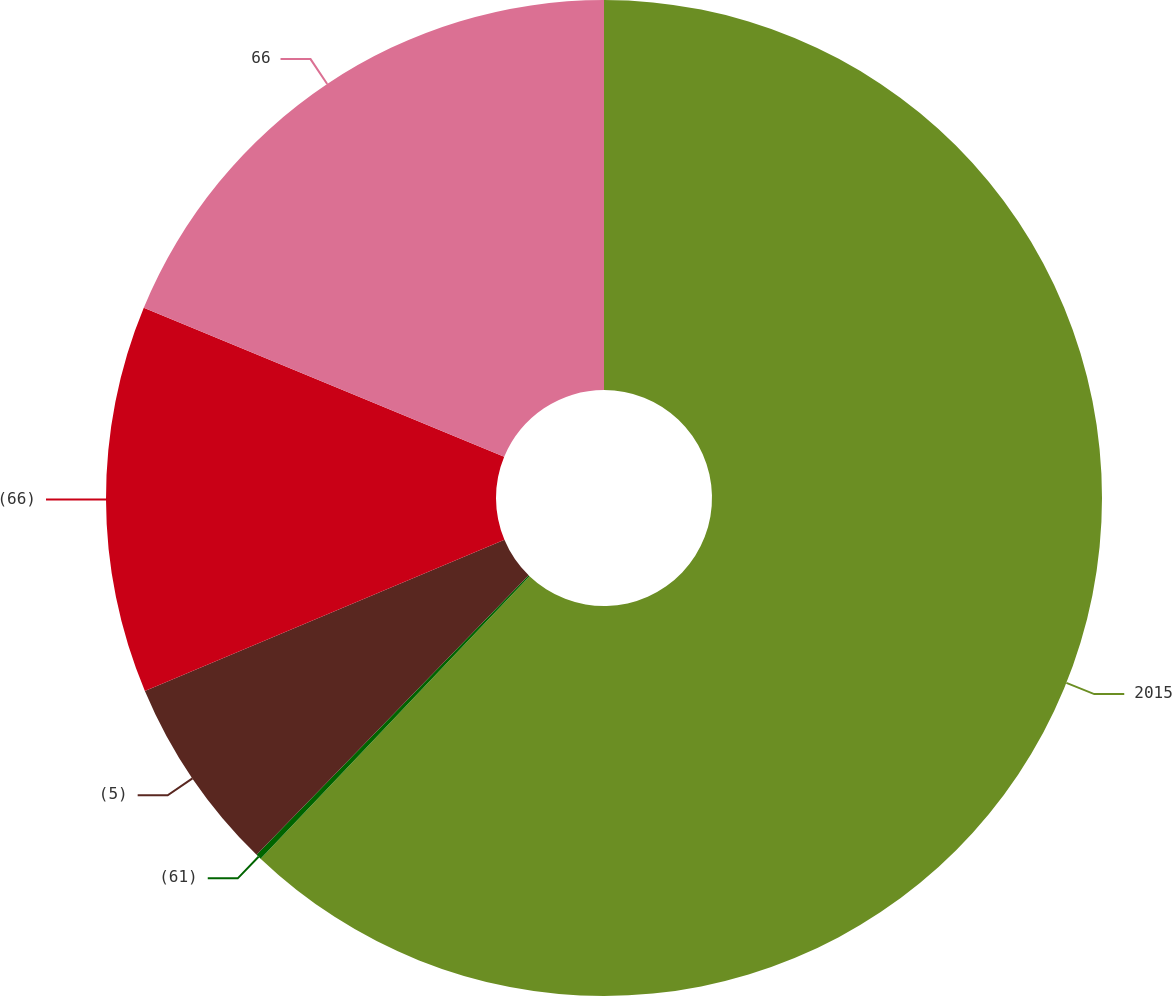Convert chart. <chart><loc_0><loc_0><loc_500><loc_500><pie_chart><fcel>2015<fcel>(61)<fcel>(5)<fcel>(66)<fcel>66<nl><fcel>62.11%<fcel>0.18%<fcel>6.38%<fcel>12.57%<fcel>18.76%<nl></chart> 